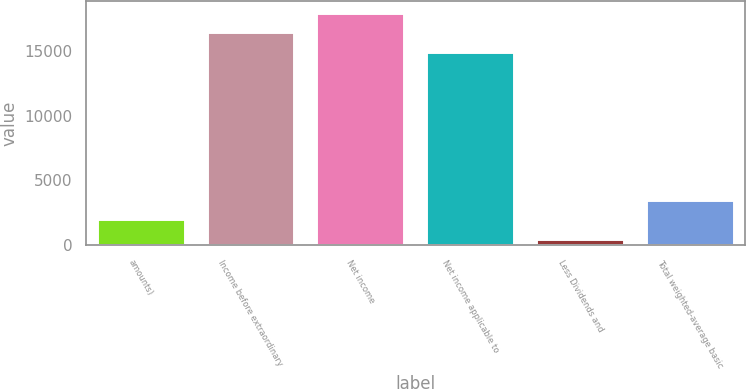<chart> <loc_0><loc_0><loc_500><loc_500><bar_chart><fcel>amounts)<fcel>Income before extraordinary<fcel>Net income<fcel>Net income applicable to<fcel>Less Dividends and<fcel>Total weighted-average basic<nl><fcel>2007<fcel>16416.4<fcel>17908.8<fcel>14924<fcel>441<fcel>3499.4<nl></chart> 